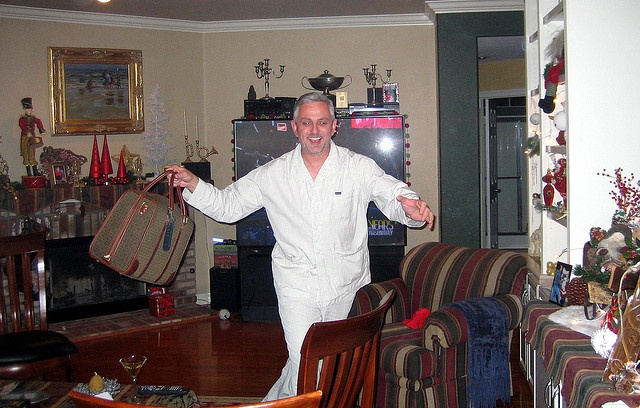Describe the objects in this image and their specific colors. I can see people in black, lightgray, darkgray, lightpink, and brown tones, couch in black, maroon, gray, and navy tones, chair in black, maroon, navy, and gray tones, tv in black, gray, navy, and darkgray tones, and handbag in black, gray, and maroon tones in this image. 